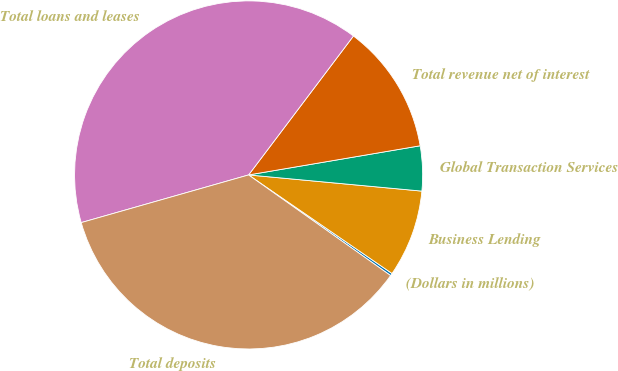<chart> <loc_0><loc_0><loc_500><loc_500><pie_chart><fcel>(Dollars in millions)<fcel>Business Lending<fcel>Global Transaction Services<fcel>Total revenue net of interest<fcel>Total loans and leases<fcel>Total deposits<nl><fcel>0.23%<fcel>8.1%<fcel>4.16%<fcel>12.03%<fcel>39.7%<fcel>35.77%<nl></chart> 